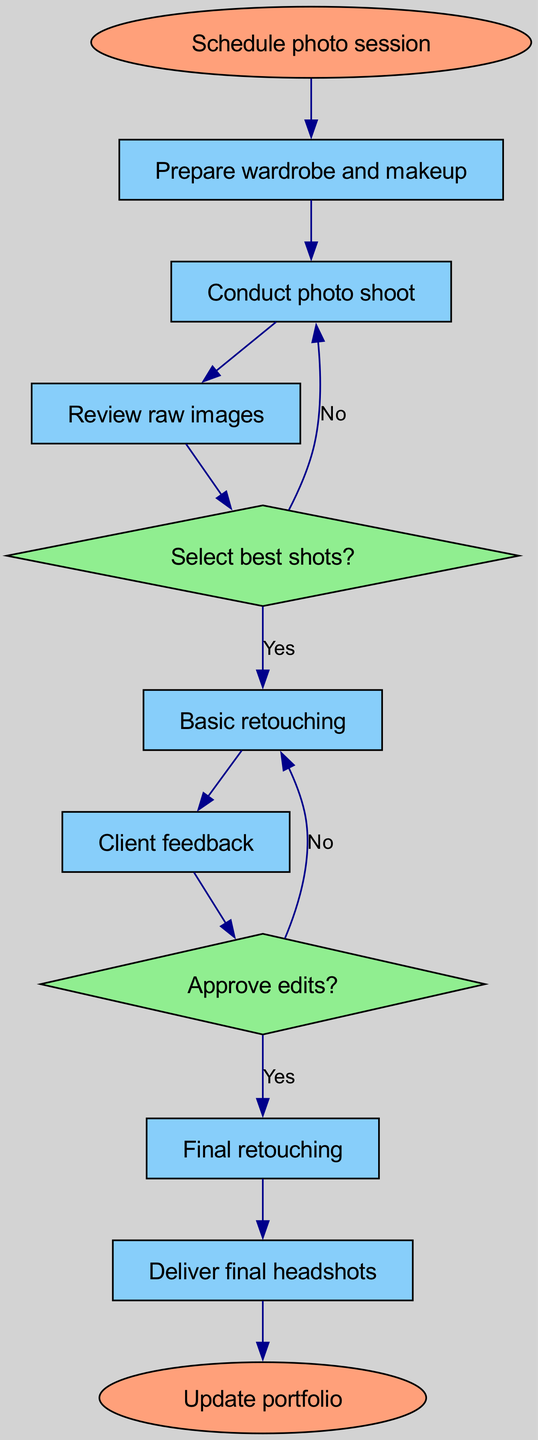What is the first step in the process? The first step in the process is indicated as "Schedule photo session," which is the initial node in the flowchart.
Answer: Schedule photo session How many decision points are in the diagram? The diagram contains two decision points labeled as "Select best shots?" and "Approve edits?" Thus, the total number of decision points is two.
Answer: 2 What happens if the best shots are not selected? If the best shots are not selected, the flowchart shows a return to the "Conduct photo shoot" node, indicating that more shots need to be taken.
Answer: Conduct photo shoot What comes after "Client feedback"? Following "Client feedback," the next node in the diagram is "Approve edits?" which indicates that client feedback leads to another decision point regarding the edits.
Answer: Approve edits? What is the final step of the process? The final step in the diagram is "Update portfolio," which indicates the conclusion of the entire headshot selection and retouching process.
Answer: Update portfolio What is the relationship between "Basic retouching" and "Final retouching"? "Basic retouching" is an initial step that leads to "Client feedback," while "Final retouching" occurs after the edits are approved, illustrating a linear progression in the retouching process.
Answer: Linear progression If the edits are not approved, what step is taken next? If the edits are not approved, the flowchart indicates a return to "Basic retouching," requiring further modifications based on client feedback before resubmission for approval.
Answer: Basic retouching How many nodes are in the flowchart? The flowchart consists of a total of 9 distinct nodes outlining various steps and decisions in the process.
Answer: 9 What color are the decision nodes represented in the diagram? The decision nodes in the flowchart are represented in light green, which distinguishes them from other types of nodes like rectangles for regular steps.
Answer: Light green 